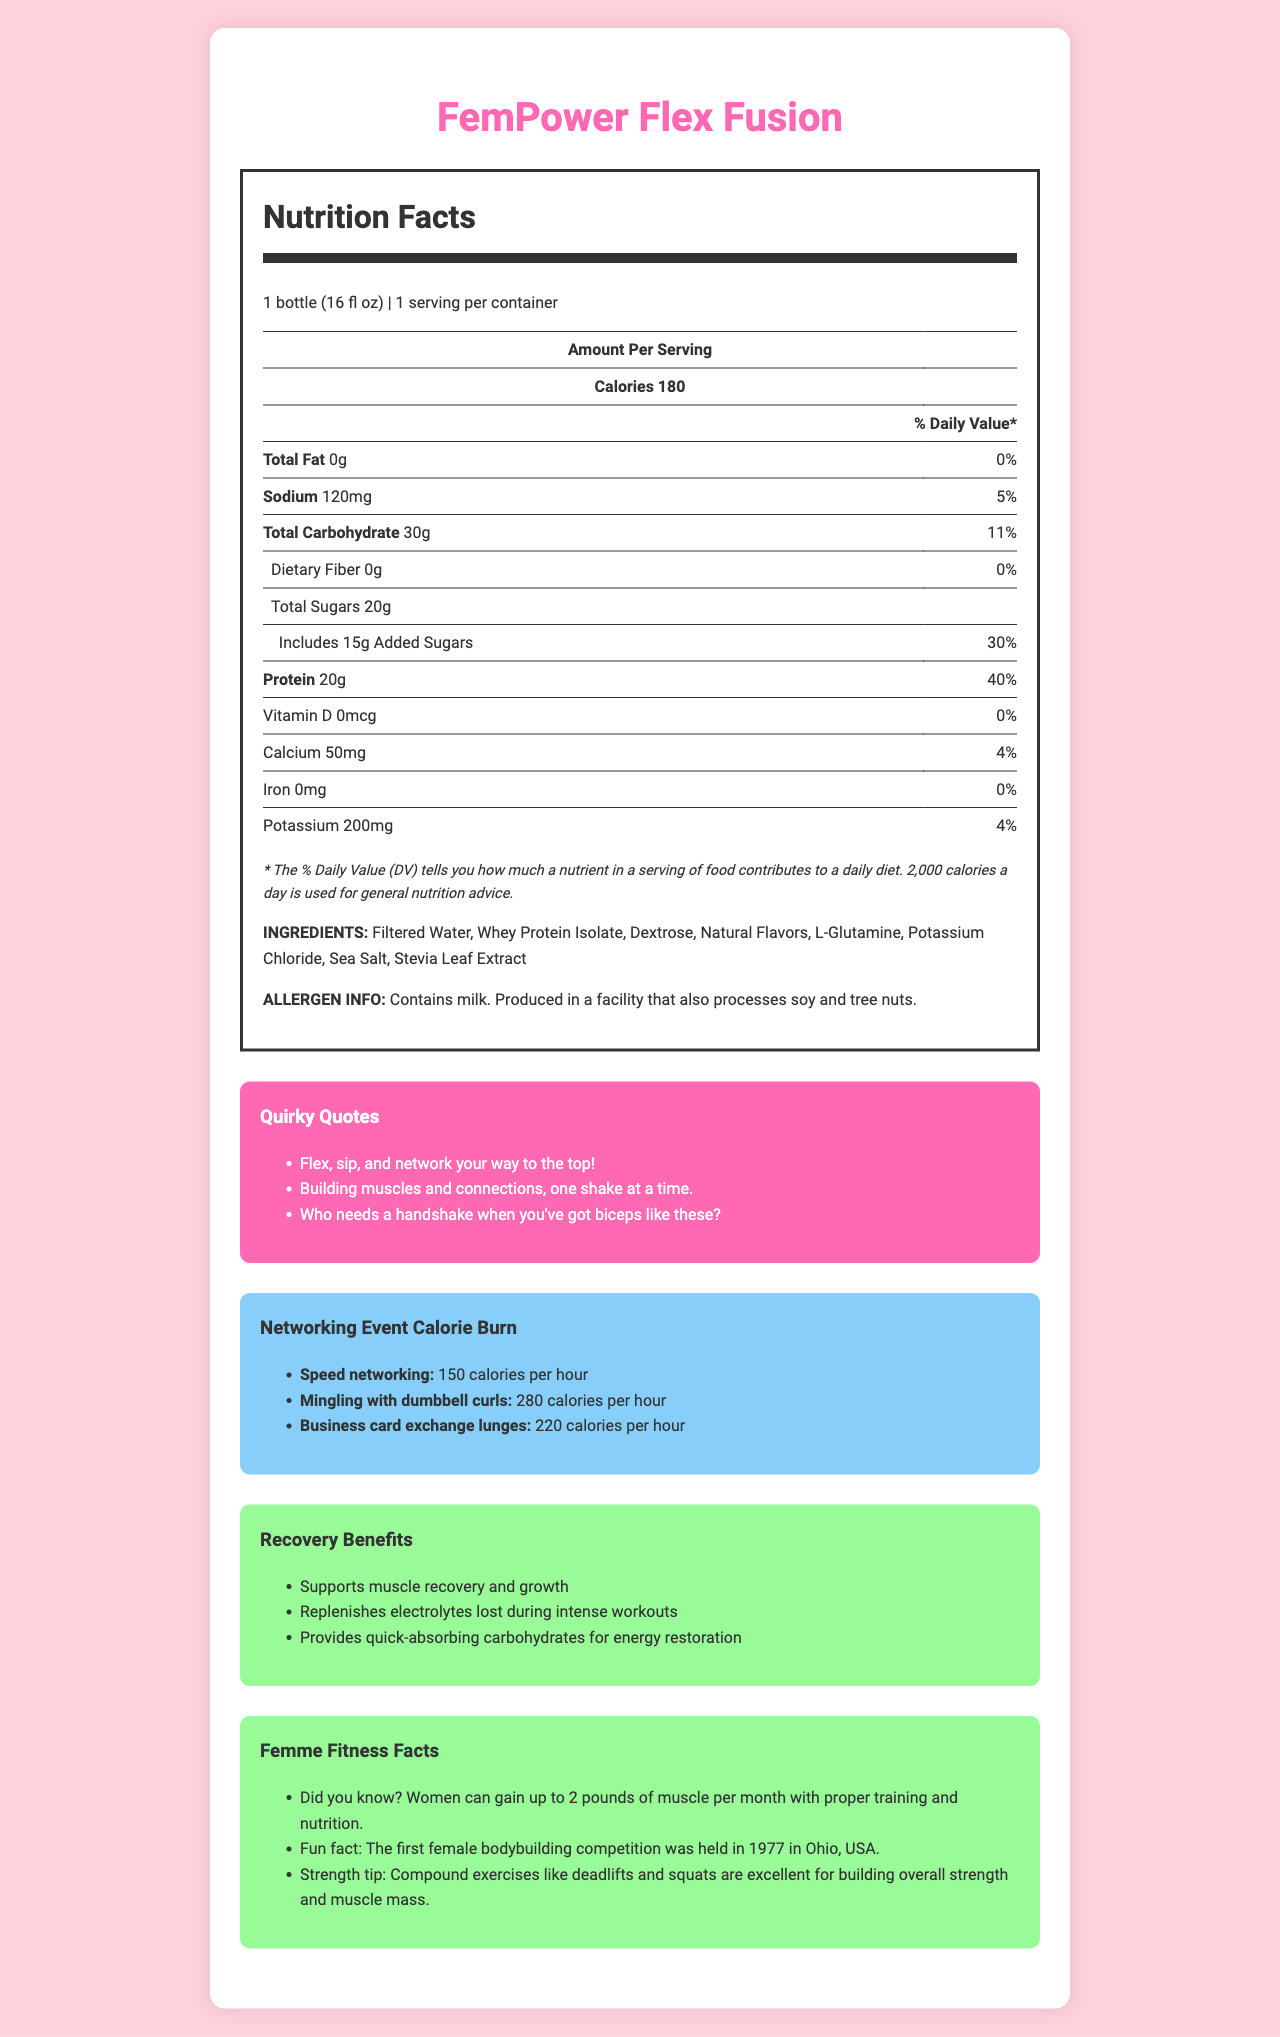what is the product name? The product name is displayed prominently at the top of the document.
Answer: FemPower Flex Fusion how many calories are in one serving? The document states that one serving size is one bottle (16 fl oz) and contains 180 calories.
Answer: 180 calories what is the total carbohydrate content per serving? The nutrition facts table lists the total carbohydrate content as 30g for one serving.
Answer: 30g how much protein does one bottle contain? The protein content per serving is 20g, as indicated in the nutrition facts.
Answer: 20g what are the main ingredients? The ingredients list includes all these items, which are mentioned in the nutrition facts section.
Answer: Filtered Water, Whey Protein Isolate, Dextrose, Natural Flavors, L-Glutamine, Potassium Chloride, Sea Salt, Stevia Leaf Extract which quirky quote is included? A. "Who needs a handshake when you've got biceps like these?" B. "Flex, sip, and dominate" C. "Sculpt your dreams, one rep at a time" D. "Stay strong and spark joy" One of the quirky quotes listed is "Who needs a handshake when you've got biceps like these?"
Answer: A how many calories can you burn while mingling with dumbbell curls for an hour? A. 150 B. 180 C. 220 D. 280 The document states that mingling with dumbbell curls can burn 280 calories per hour.
Answer: D is this product allergen-free? The allergen information states that it contains milk and is produced in a facility that also processes soy and tree nuts.
Answer: No summarize the main idea of the document. The document aims to inform consumers about the nutritional content, potential allergen risks, muscle recovery benefits, and fun facts related to "FemPower Flex Fusion."
Answer: The document provides detailed nutrition facts, ingredients, allergen info, quirky quotes, calorie burn estimates for various networking activities, recovery benefits, and fitness facts related to the post-workout recovery drink "FemPower Flex Fusion." can the document help determine how much iron the product contains? The nutrition facts section explicitly mentions that there is 0mg of iron per serving.
Answer: Yes, it contains 0mg of iron. how much calcium is in the product? The nutrition facts section lists the calcium content as 50mg per serving.
Answer: 50mg what recovery benefits does the drink offer? The recovery benefits section lists all these points.
Answer: Supports muscle recovery and growth, replenishes electrolytes lost during intense workouts, provides quick-absorbing carbohydrates for energy restoration who might want to avoid this product based on allergen information? The allergen information section mentions that the product contains milk and is produced in a facility that processes soy and tree nuts.
Answer: People who are allergic to milk, soy, or tree nuts does the document mention the first female bodybuilding competition? The Femme Fitness Facts section mentions that the first female bodybuilding competition was held in 1977 in Ohio, USA.
Answer: Yes how can you burn more calories than speed networking while attending a networking event? (Choose all that apply) I. Mingling with dumbbell curls II. Business card exchange lunges III. Speed walking meetings According to the calorie burn section, mingling with dumbbell curls burns 280 calories per hour and business card exchange lunges burn 220 calories per hour, both of which are higher than speed networking at 150 calories per hour.
Answer: I, II what should someone do to build overall strength and muscle mass? The Femme Fitness Facts section suggests that compound exercises like deadlifts and squats are excellent for building overall strength and muscle mass.
Answer: Perform compound exercises like deadlifts and squats how much dietary fiber does the drink provide? The nutrition facts section lists the dietary fiber content as 0g per serving.
Answer: 0g who manufactures FemPower Flex Fusion? The document does not provide information about the manufacturer.
Answer: Cannot be determined 